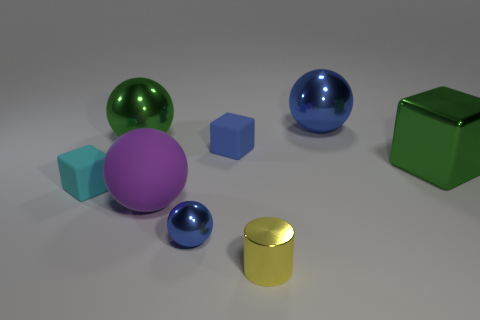Subtract all gray cylinders. Subtract all blue blocks. How many cylinders are left? 1 Add 1 cylinders. How many objects exist? 9 Subtract all blocks. How many objects are left? 5 Add 5 tiny cyan rubber cubes. How many tiny cyan rubber cubes are left? 6 Add 7 large rubber balls. How many large rubber balls exist? 8 Subtract 0 yellow spheres. How many objects are left? 8 Subtract all yellow metallic objects. Subtract all big green blocks. How many objects are left? 6 